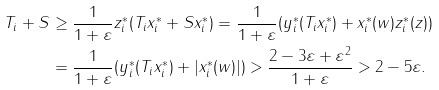Convert formula to latex. <formula><loc_0><loc_0><loc_500><loc_500>\| T _ { i } + S \| & \geq \frac { 1 } { 1 + \varepsilon } z _ { i } ^ { * } ( T _ { i } x _ { i } ^ { * } + S x _ { i } ^ { * } ) = \frac { 1 } { 1 + \varepsilon } ( y _ { i } ^ { * } ( T _ { i } x _ { i } ^ { * } ) + x _ { i } ^ { * } ( w ) z _ { i } ^ { * } ( z ) ) \\ & = \frac { 1 } { 1 + \varepsilon } ( y _ { i } ^ { * } ( T _ { i } x _ { i } ^ { * } ) + | x _ { i } ^ { * } ( w ) | ) > \frac { 2 - 3 \varepsilon + \varepsilon ^ { 2 } } { 1 + \varepsilon } > 2 - 5 \varepsilon .</formula> 